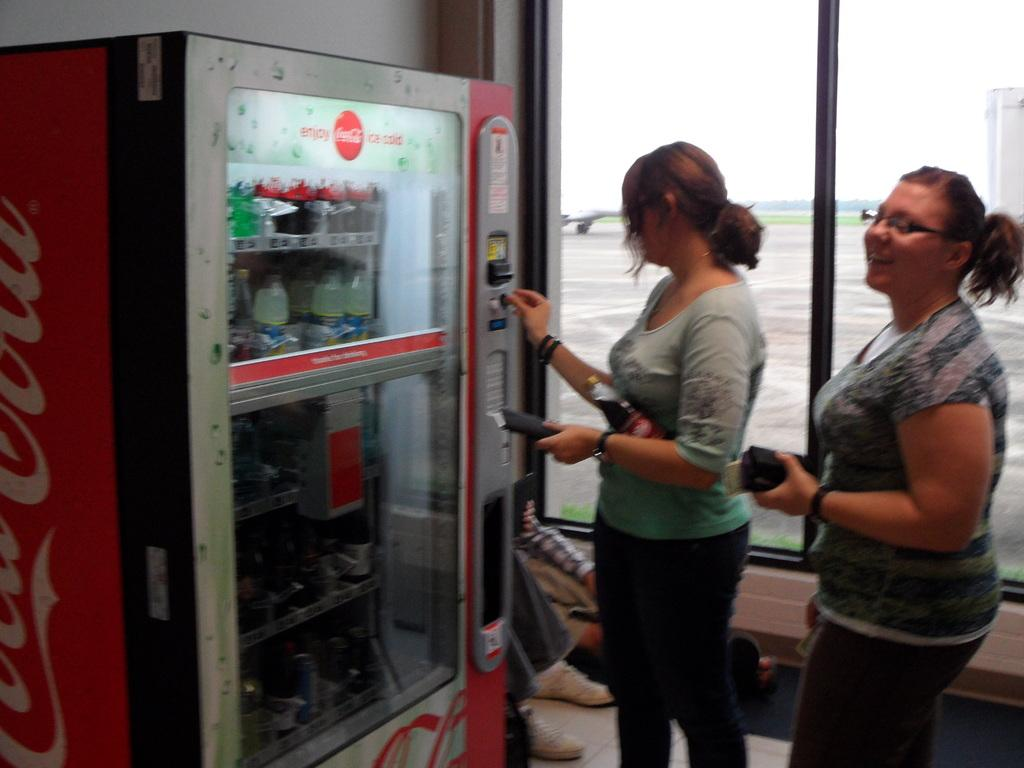<image>
Share a concise interpretation of the image provided. Two girls are getting drinks from a Coca Cola machine. 